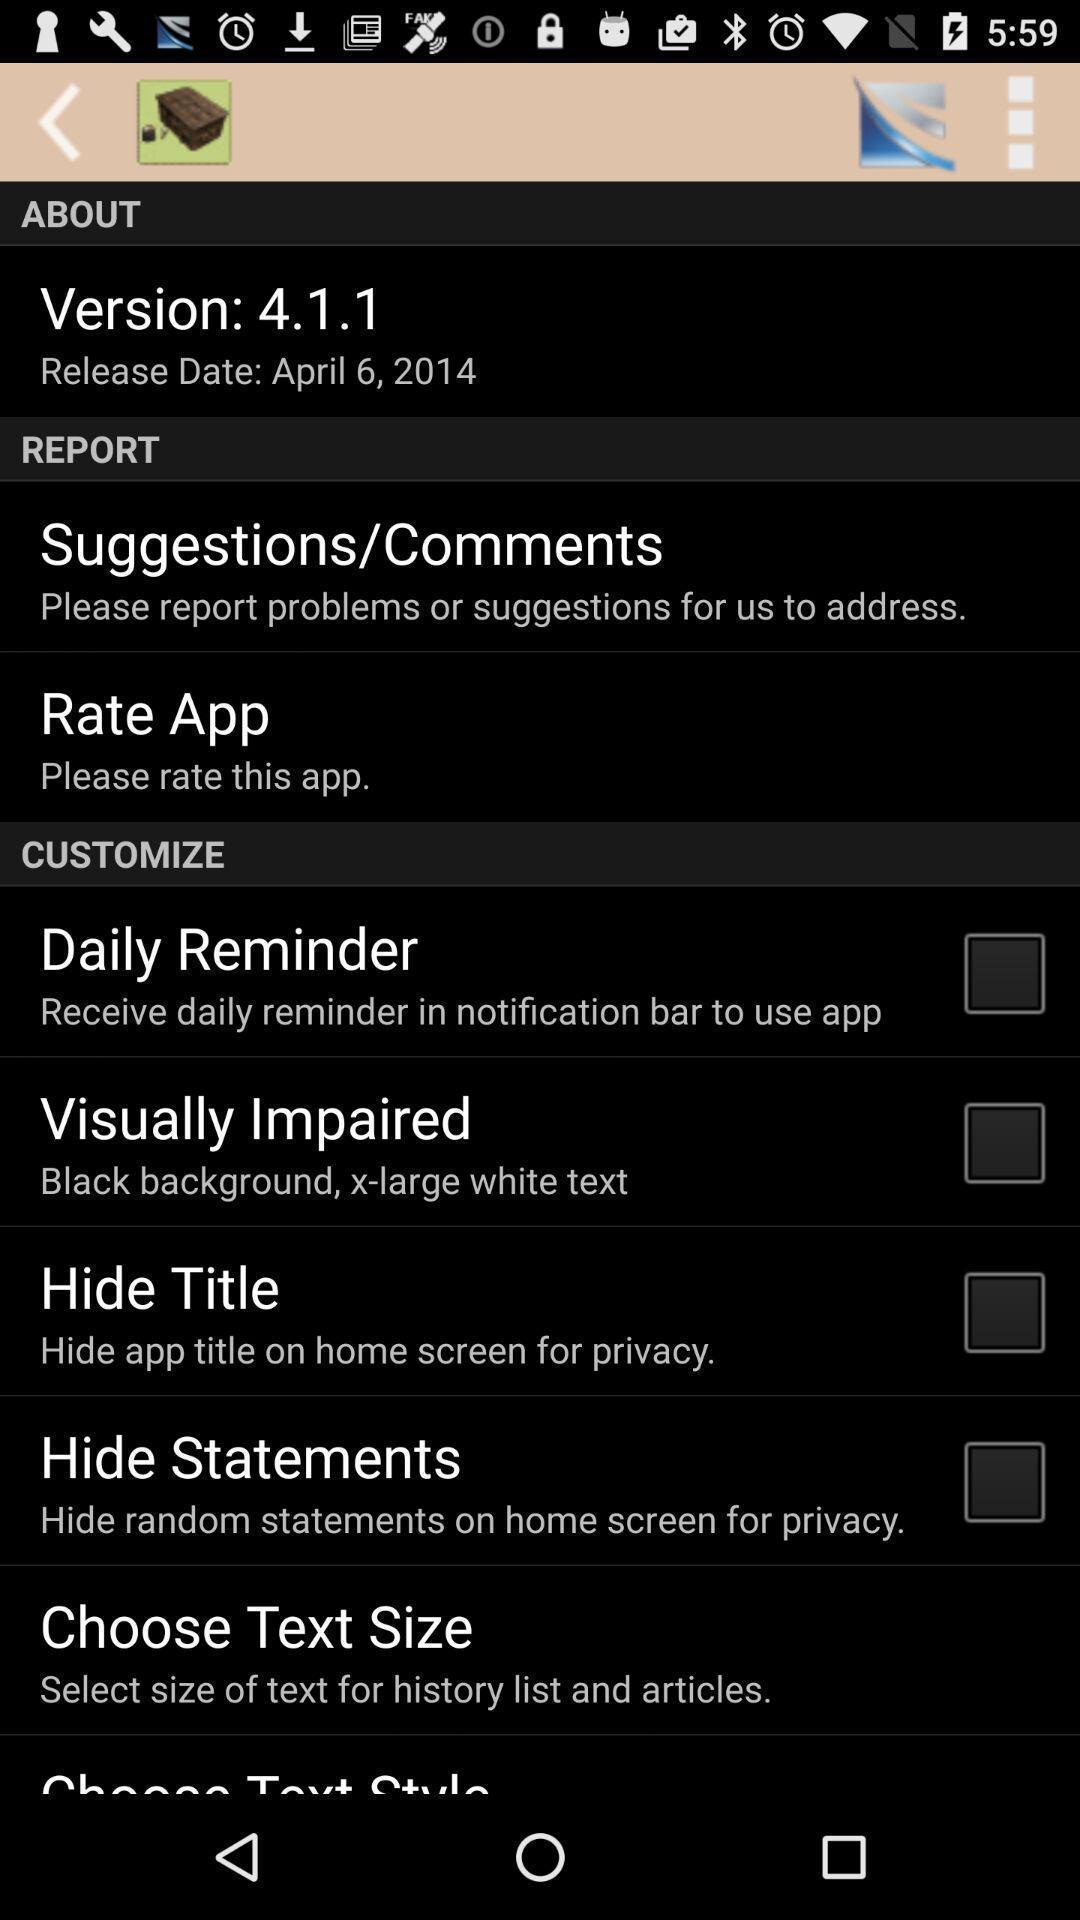What is the overall content of this screenshot? Page showing options of version of app. 